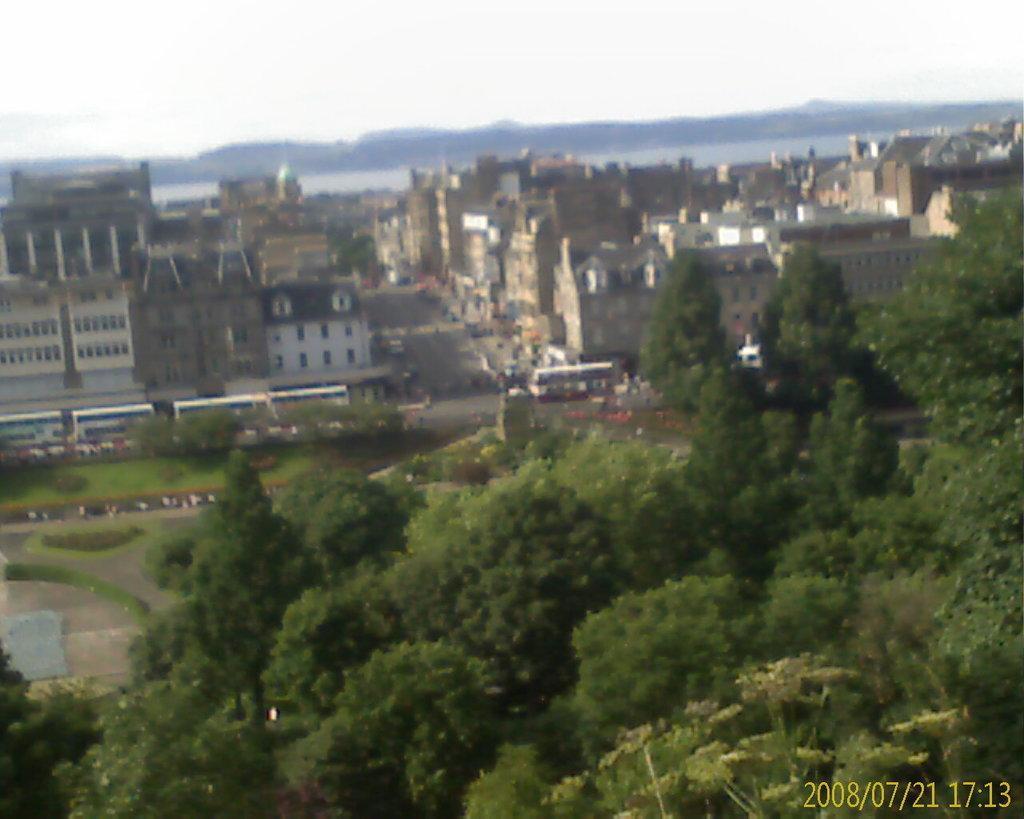How would you summarize this image in a sentence or two? This picture is taken outside. At the bottom, there are trees. In the center, there are buildings. In middle of the buildings, there are roads. On the road, there are vehicles. On the top, there are hills and sky. 